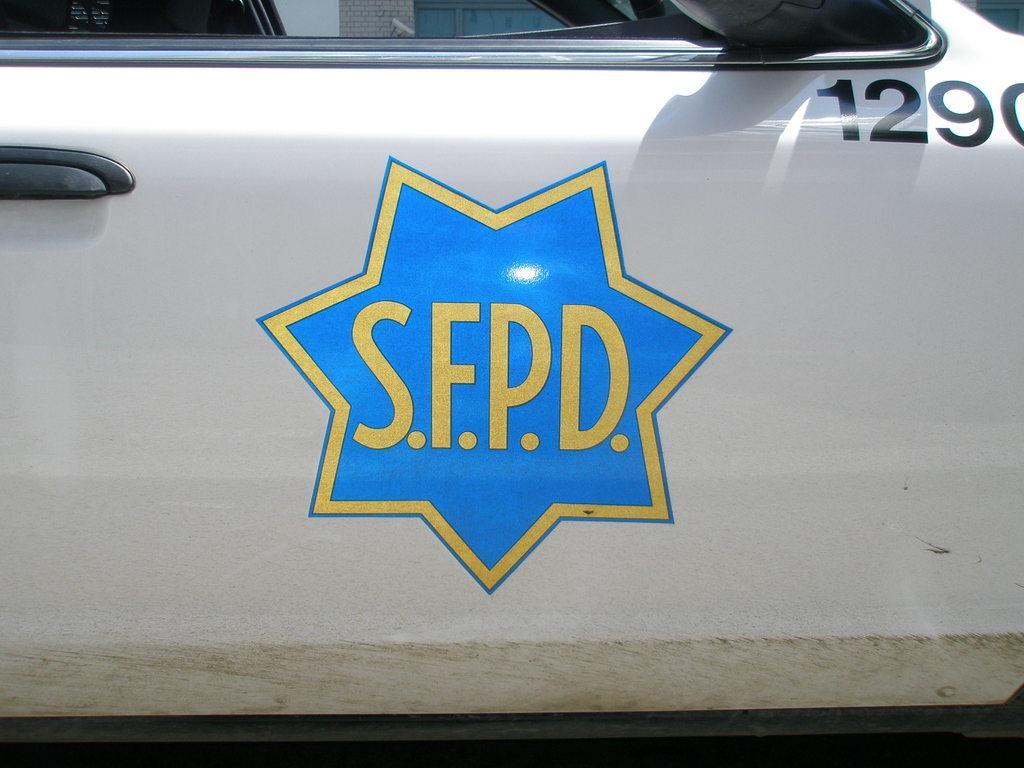Describe this image in one or two sentences. In the image we can see a vehicle, on the vehicle there is logo. 